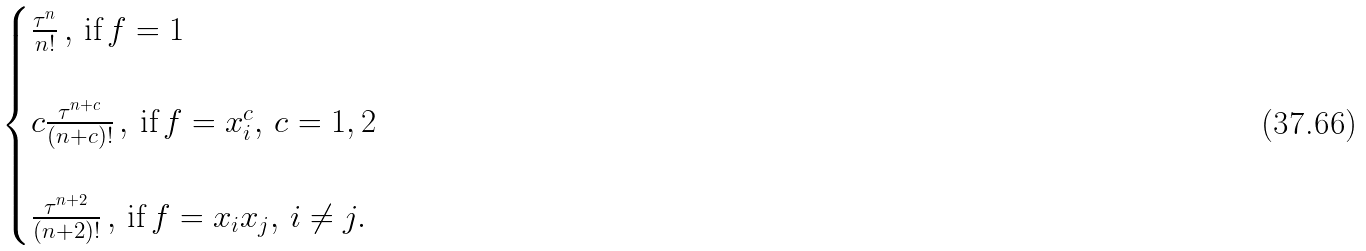<formula> <loc_0><loc_0><loc_500><loc_500>\begin{cases} \frac { \tau ^ { n } } { n ! } \, , \, \text {if} \, f = 1 \\ \\ c \frac { \tau ^ { n + c } } { ( n + c ) ! } \, , \, \text {if} \, f = x _ { i } ^ { c } , \, c = 1 , 2 \\ \\ \frac { \tau ^ { n + 2 } } { ( n + 2 ) ! } \, , \, \text {if} \, f = x _ { i } x _ { j } , \, i \ne j . \end{cases}</formula> 